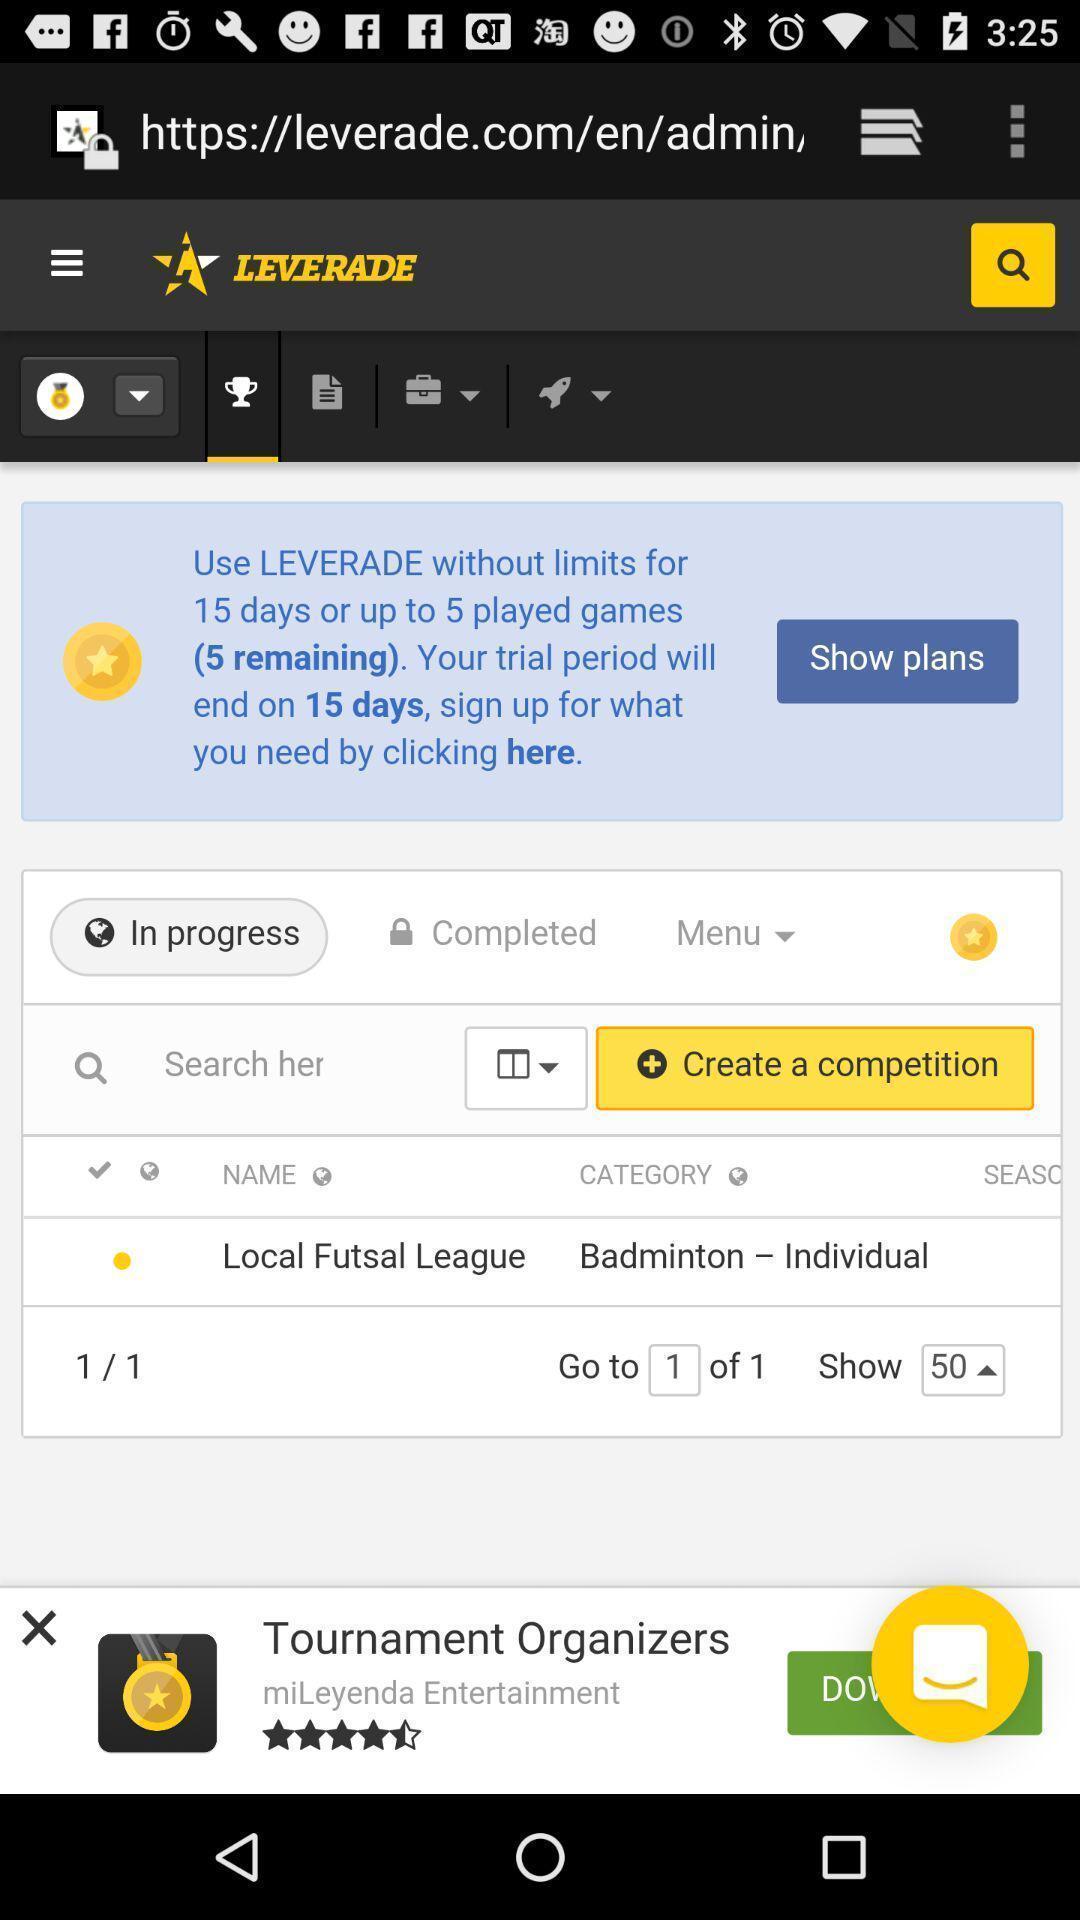Give me a summary of this screen capture. Screen displaying multiple options in a sports league management application. 